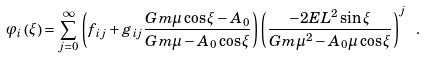<formula> <loc_0><loc_0><loc_500><loc_500>\varphi _ { i } \left ( \xi \right ) = \sum _ { j = 0 } ^ { \infty } \left ( f _ { i j } + g _ { i j } \frac { G m \mu \cos \xi - A _ { 0 } } { G m \mu - A _ { 0 } \cos \xi } \right ) \left ( \frac { - 2 E L ^ { 2 } \sin \xi } { G m \mu ^ { 2 } - A _ { 0 } \mu \cos \xi } \right ) ^ { j } \ .</formula> 